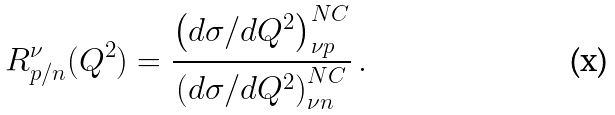<formula> <loc_0><loc_0><loc_500><loc_500>R _ { p / n } ^ { \nu } ( Q ^ { 2 } ) = \frac { \left ( d \sigma / d Q ^ { 2 } \right ) _ { \nu p } ^ { N C } } { \left ( d \sigma / d Q ^ { 2 } \right ) _ { \nu n } ^ { N C } } \, .</formula> 